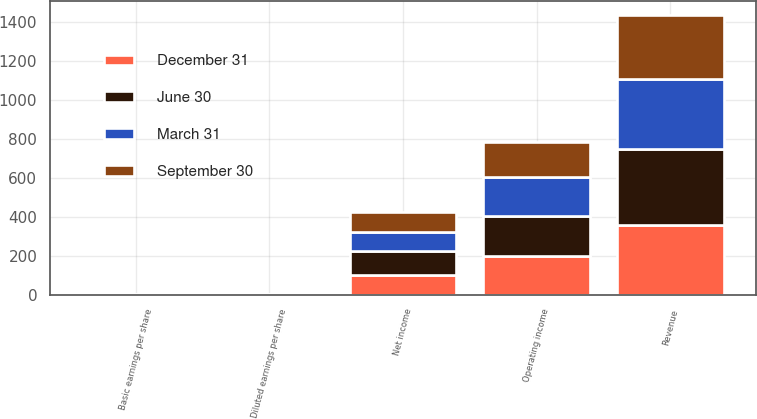Convert chart. <chart><loc_0><loc_0><loc_500><loc_500><stacked_bar_chart><ecel><fcel>Revenue<fcel>Operating income<fcel>Net income<fcel>Basic earnings per share<fcel>Diluted earnings per share<nl><fcel>September 30<fcel>331.2<fcel>182.9<fcel>103.5<fcel>0.69<fcel>0.68<nl><fcel>December 31<fcel>357.6<fcel>199.5<fcel>103.5<fcel>0.7<fcel>0.68<nl><fcel>March 31<fcel>357.9<fcel>197.8<fcel>95.5<fcel>0.65<fcel>0.63<nl><fcel>June 30<fcel>391.6<fcel>206.2<fcel>122.6<fcel>0.83<fcel>0.8<nl></chart> 